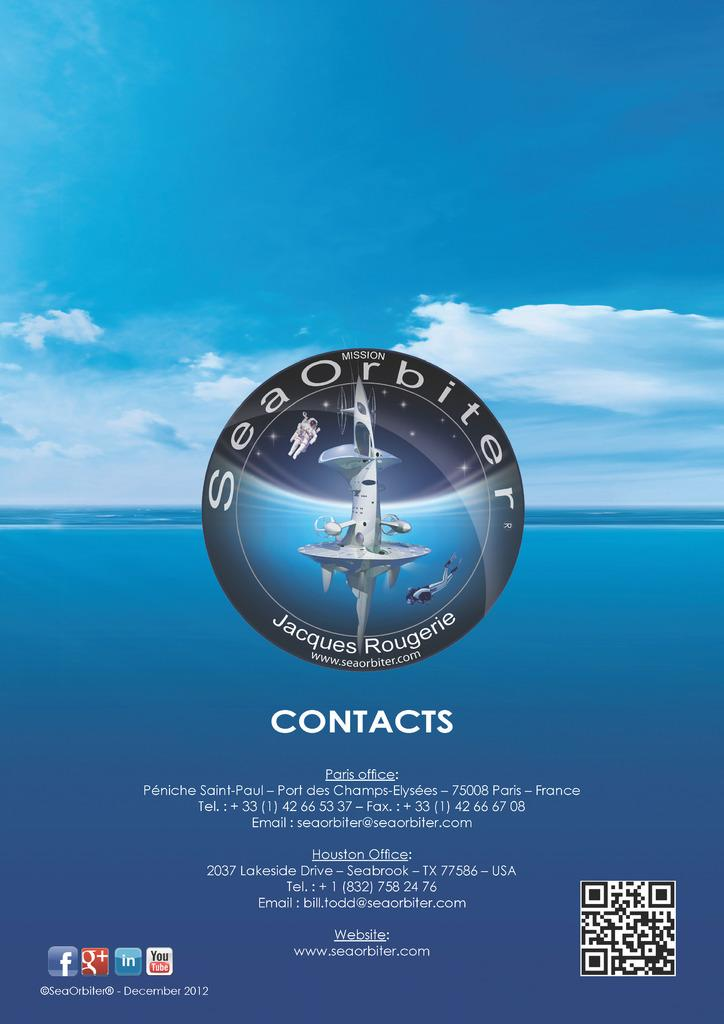What can be found in the image that represents companies or brands? There are logos in the image that represent companies or brands. How do the logos differ from each other? The logos are in different colors. What information is included on the logos? There is text written on the logos. What type of code is present at the bottom of the image? There is a barcode at the bottom of the image. What are the main colors used in the background of the image? The background color of the image is blue and white. What type of discussion is taking place in the image? There is no discussion taking place in the image; it only contains logos, text, and a barcode. 